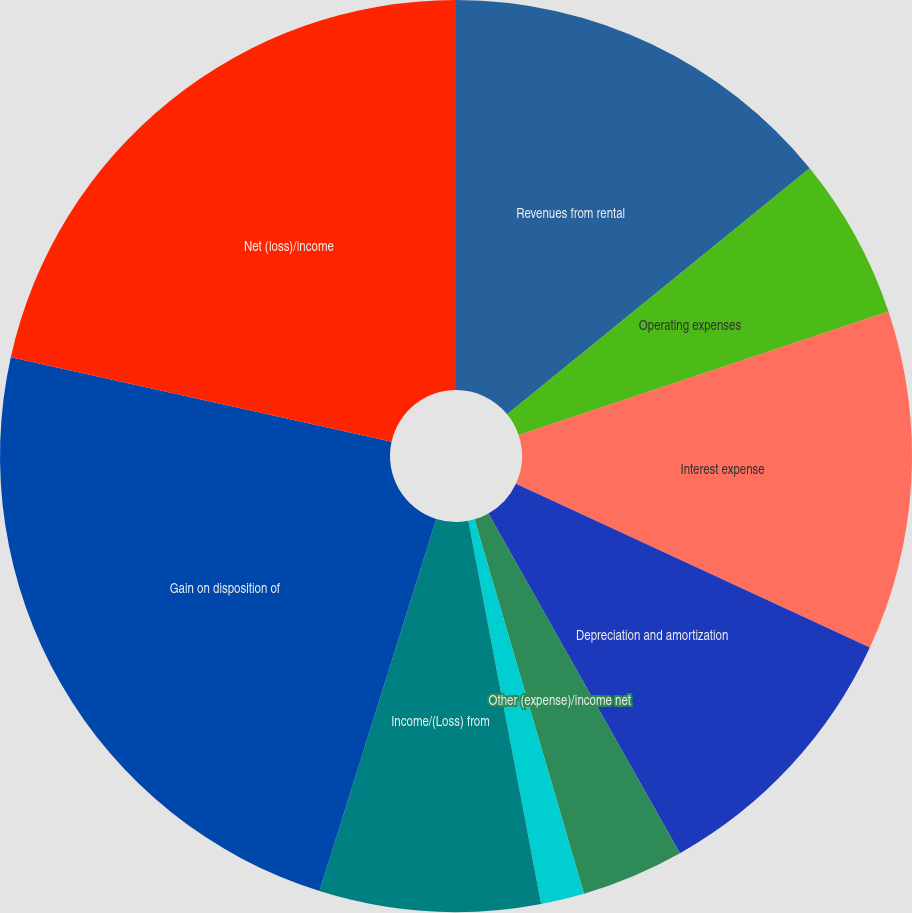Convert chart to OTSL. <chart><loc_0><loc_0><loc_500><loc_500><pie_chart><fcel>Revenues from rental<fcel>Operating expenses<fcel>Interest expense<fcel>Depreciation and amortization<fcel>Other (expense)/income net<fcel>(Loss)/Income from continuing<fcel>Income/(Loss) from<fcel>Gain on disposition of<fcel>Net (loss)/income<nl><fcel>14.13%<fcel>5.74%<fcel>12.03%<fcel>9.93%<fcel>3.64%<fcel>1.54%<fcel>7.83%<fcel>23.63%<fcel>21.53%<nl></chart> 